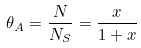Convert formula to latex. <formula><loc_0><loc_0><loc_500><loc_500>\theta _ { A } = \frac { N } { N _ { S } } = \frac { x } { 1 + x }</formula> 